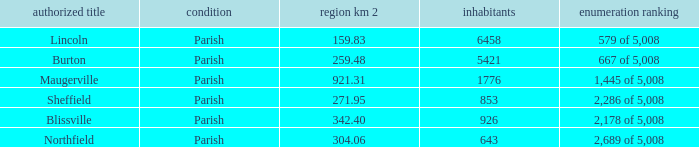What is the status(es) of the place with an area of 304.06 km2? Parish. 